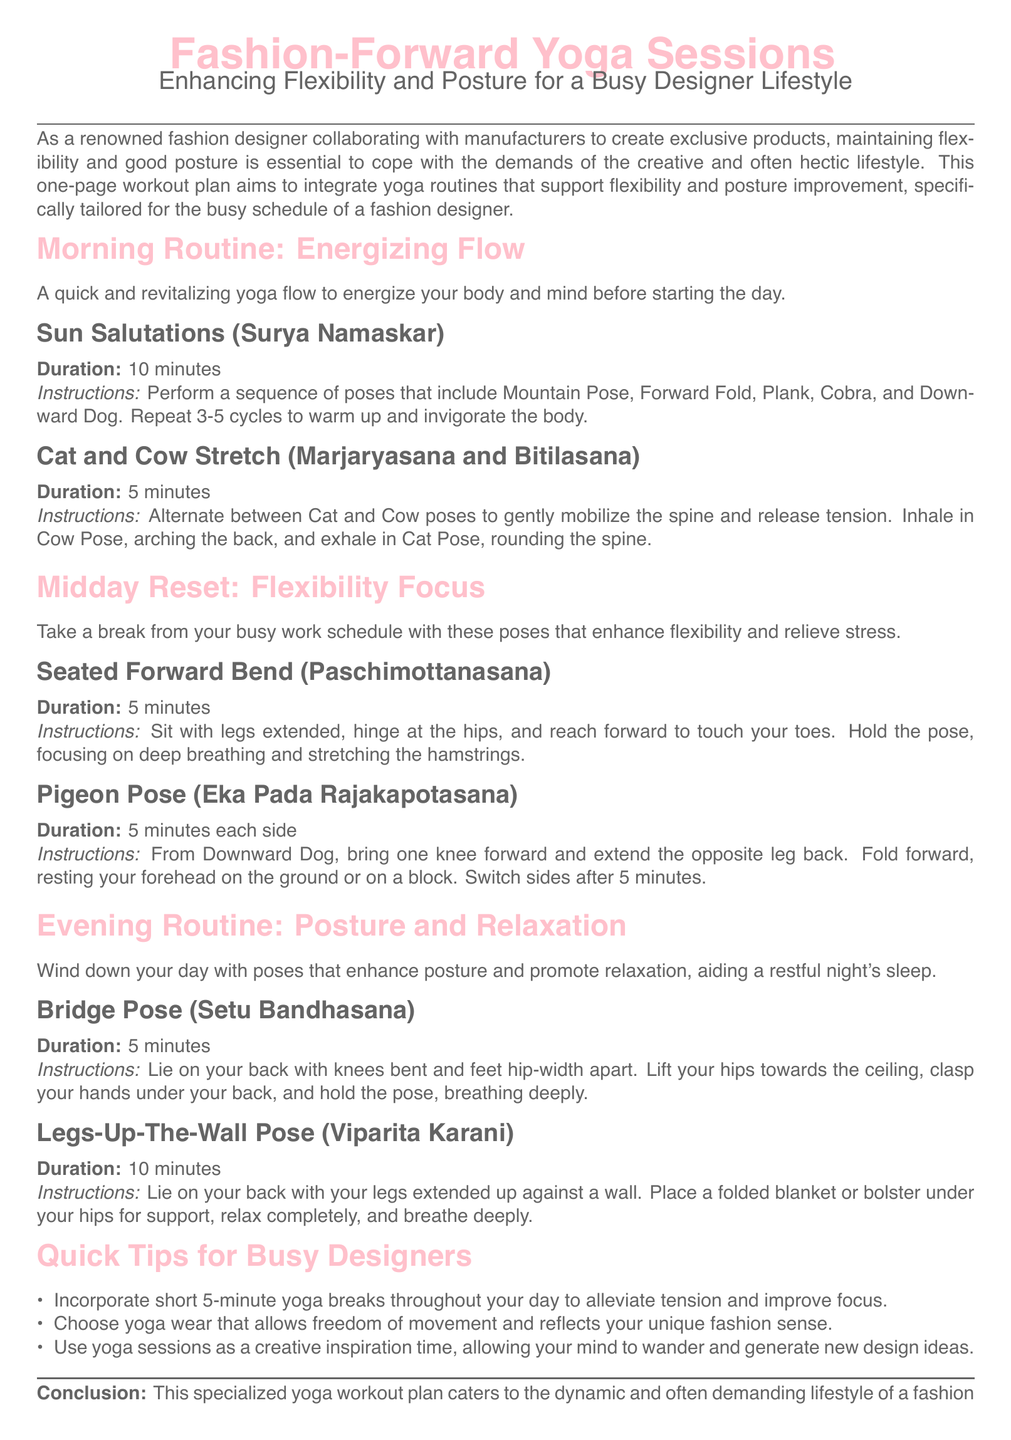What is the title of the workout plan? The title of the workout plan is prominently displayed at the top of the document.
Answer: Fashion-Forward Yoga Sessions What is the main focus of the yoga sessions? The main focus of the yoga sessions is stated in the subtitle of the workout plan.
Answer: Enhancing Flexibility and Posture How long should the Sun Salutations be performed? The duration for Sun Salutations is specified in the routine section of the document.
Answer: 10 minutes What is the duration for each side of Pigeon Pose? This information is mentioned in the instructions for the Pigeon Pose.
Answer: 5 minutes What type of poses are included in the evening routine? The content of the evening routine indicates the main purpose of the poses.
Answer: Posture and Relaxation What is a quick tip for busy designers mentioned in the document? The tips section provides practical advice tailored for busy designers.
Answer: Incorporate short 5-minute yoga breaks Which pose is suggested for the midday reset? The document specifies a particular pose to focus on during the midday reset.
Answer: Seated Forward Bend What should yoga wear reflect for designers? The document advises that yoga wear should have a specific attribute.
Answer: Unique fashion sense What is the total duration of the Legs-Up-The-Wall Pose? The duration for this specific pose is clearly outlined in the routine section.
Answer: 10 minutes 